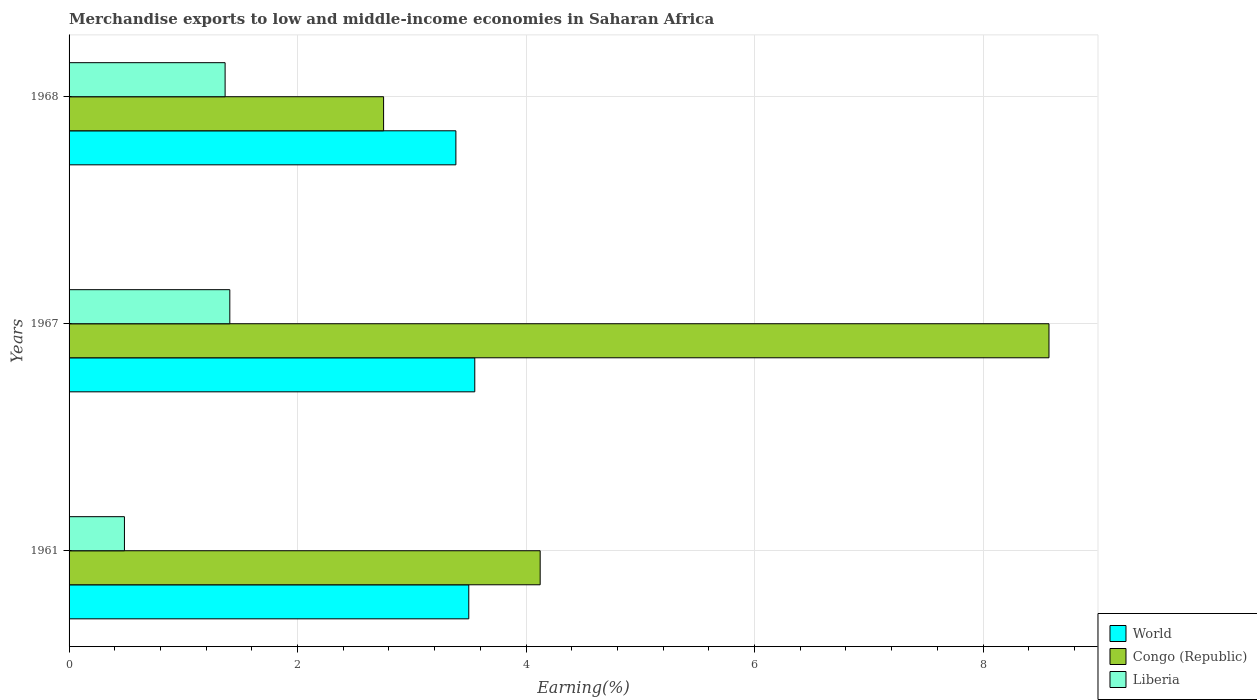Are the number of bars per tick equal to the number of legend labels?
Your answer should be compact. Yes. Are the number of bars on each tick of the Y-axis equal?
Keep it short and to the point. Yes. How many bars are there on the 1st tick from the top?
Keep it short and to the point. 3. How many bars are there on the 3rd tick from the bottom?
Make the answer very short. 3. What is the percentage of amount earned from merchandise exports in World in 1968?
Offer a very short reply. 3.39. Across all years, what is the maximum percentage of amount earned from merchandise exports in Liberia?
Your answer should be compact. 1.41. Across all years, what is the minimum percentage of amount earned from merchandise exports in Liberia?
Your answer should be very brief. 0.48. In which year was the percentage of amount earned from merchandise exports in Congo (Republic) maximum?
Provide a succinct answer. 1967. In which year was the percentage of amount earned from merchandise exports in World minimum?
Offer a terse response. 1968. What is the total percentage of amount earned from merchandise exports in Liberia in the graph?
Your answer should be compact. 3.26. What is the difference between the percentage of amount earned from merchandise exports in Congo (Republic) in 1961 and that in 1967?
Ensure brevity in your answer.  -4.45. What is the difference between the percentage of amount earned from merchandise exports in Liberia in 1961 and the percentage of amount earned from merchandise exports in Congo (Republic) in 1968?
Offer a terse response. -2.27. What is the average percentage of amount earned from merchandise exports in World per year?
Make the answer very short. 3.48. In the year 1967, what is the difference between the percentage of amount earned from merchandise exports in World and percentage of amount earned from merchandise exports in Congo (Republic)?
Your answer should be very brief. -5.03. In how many years, is the percentage of amount earned from merchandise exports in Congo (Republic) greater than 8 %?
Make the answer very short. 1. What is the ratio of the percentage of amount earned from merchandise exports in Congo (Republic) in 1967 to that in 1968?
Make the answer very short. 3.12. What is the difference between the highest and the second highest percentage of amount earned from merchandise exports in Congo (Republic)?
Make the answer very short. 4.45. What is the difference between the highest and the lowest percentage of amount earned from merchandise exports in Congo (Republic)?
Offer a very short reply. 5.82. What does the 1st bar from the top in 1961 represents?
Your answer should be compact. Liberia. Does the graph contain any zero values?
Give a very brief answer. No. Where does the legend appear in the graph?
Give a very brief answer. Bottom right. How many legend labels are there?
Offer a very short reply. 3. What is the title of the graph?
Offer a very short reply. Merchandise exports to low and middle-income economies in Saharan Africa. Does "Kenya" appear as one of the legend labels in the graph?
Provide a short and direct response. No. What is the label or title of the X-axis?
Provide a succinct answer. Earning(%). What is the Earning(%) in World in 1961?
Offer a terse response. 3.5. What is the Earning(%) in Congo (Republic) in 1961?
Offer a terse response. 4.12. What is the Earning(%) of Liberia in 1961?
Give a very brief answer. 0.48. What is the Earning(%) of World in 1967?
Give a very brief answer. 3.55. What is the Earning(%) in Congo (Republic) in 1967?
Ensure brevity in your answer.  8.58. What is the Earning(%) in Liberia in 1967?
Provide a short and direct response. 1.41. What is the Earning(%) of World in 1968?
Your answer should be very brief. 3.39. What is the Earning(%) in Congo (Republic) in 1968?
Give a very brief answer. 2.75. What is the Earning(%) in Liberia in 1968?
Your answer should be very brief. 1.37. Across all years, what is the maximum Earning(%) in World?
Offer a very short reply. 3.55. Across all years, what is the maximum Earning(%) in Congo (Republic)?
Offer a terse response. 8.58. Across all years, what is the maximum Earning(%) in Liberia?
Your answer should be very brief. 1.41. Across all years, what is the minimum Earning(%) in World?
Keep it short and to the point. 3.39. Across all years, what is the minimum Earning(%) in Congo (Republic)?
Keep it short and to the point. 2.75. Across all years, what is the minimum Earning(%) in Liberia?
Your response must be concise. 0.48. What is the total Earning(%) in World in the graph?
Give a very brief answer. 10.44. What is the total Earning(%) of Congo (Republic) in the graph?
Offer a terse response. 15.45. What is the total Earning(%) of Liberia in the graph?
Ensure brevity in your answer.  3.26. What is the difference between the Earning(%) in World in 1961 and that in 1967?
Keep it short and to the point. -0.05. What is the difference between the Earning(%) in Congo (Republic) in 1961 and that in 1967?
Provide a succinct answer. -4.45. What is the difference between the Earning(%) of Liberia in 1961 and that in 1967?
Your answer should be compact. -0.92. What is the difference between the Earning(%) in World in 1961 and that in 1968?
Your response must be concise. 0.11. What is the difference between the Earning(%) of Congo (Republic) in 1961 and that in 1968?
Offer a terse response. 1.37. What is the difference between the Earning(%) of Liberia in 1961 and that in 1968?
Give a very brief answer. -0.88. What is the difference between the Earning(%) in World in 1967 and that in 1968?
Make the answer very short. 0.17. What is the difference between the Earning(%) of Congo (Republic) in 1967 and that in 1968?
Your response must be concise. 5.82. What is the difference between the Earning(%) in Liberia in 1967 and that in 1968?
Your answer should be compact. 0.04. What is the difference between the Earning(%) of World in 1961 and the Earning(%) of Congo (Republic) in 1967?
Make the answer very short. -5.08. What is the difference between the Earning(%) of World in 1961 and the Earning(%) of Liberia in 1967?
Your answer should be compact. 2.09. What is the difference between the Earning(%) of Congo (Republic) in 1961 and the Earning(%) of Liberia in 1967?
Provide a short and direct response. 2.72. What is the difference between the Earning(%) of World in 1961 and the Earning(%) of Congo (Republic) in 1968?
Provide a succinct answer. 0.75. What is the difference between the Earning(%) of World in 1961 and the Earning(%) of Liberia in 1968?
Provide a succinct answer. 2.13. What is the difference between the Earning(%) of Congo (Republic) in 1961 and the Earning(%) of Liberia in 1968?
Offer a terse response. 2.76. What is the difference between the Earning(%) in World in 1967 and the Earning(%) in Congo (Republic) in 1968?
Provide a short and direct response. 0.8. What is the difference between the Earning(%) in World in 1967 and the Earning(%) in Liberia in 1968?
Make the answer very short. 2.19. What is the difference between the Earning(%) of Congo (Republic) in 1967 and the Earning(%) of Liberia in 1968?
Make the answer very short. 7.21. What is the average Earning(%) in World per year?
Your answer should be very brief. 3.48. What is the average Earning(%) of Congo (Republic) per year?
Offer a terse response. 5.15. What is the average Earning(%) in Liberia per year?
Keep it short and to the point. 1.09. In the year 1961, what is the difference between the Earning(%) of World and Earning(%) of Congo (Republic)?
Give a very brief answer. -0.62. In the year 1961, what is the difference between the Earning(%) in World and Earning(%) in Liberia?
Your response must be concise. 3.01. In the year 1961, what is the difference between the Earning(%) in Congo (Republic) and Earning(%) in Liberia?
Give a very brief answer. 3.64. In the year 1967, what is the difference between the Earning(%) of World and Earning(%) of Congo (Republic)?
Ensure brevity in your answer.  -5.03. In the year 1967, what is the difference between the Earning(%) in World and Earning(%) in Liberia?
Make the answer very short. 2.14. In the year 1967, what is the difference between the Earning(%) in Congo (Republic) and Earning(%) in Liberia?
Keep it short and to the point. 7.17. In the year 1968, what is the difference between the Earning(%) in World and Earning(%) in Congo (Republic)?
Make the answer very short. 0.63. In the year 1968, what is the difference between the Earning(%) of World and Earning(%) of Liberia?
Give a very brief answer. 2.02. In the year 1968, what is the difference between the Earning(%) of Congo (Republic) and Earning(%) of Liberia?
Your response must be concise. 1.39. What is the ratio of the Earning(%) in World in 1961 to that in 1967?
Make the answer very short. 0.99. What is the ratio of the Earning(%) of Congo (Republic) in 1961 to that in 1967?
Offer a terse response. 0.48. What is the ratio of the Earning(%) in Liberia in 1961 to that in 1967?
Offer a very short reply. 0.34. What is the ratio of the Earning(%) of Congo (Republic) in 1961 to that in 1968?
Provide a short and direct response. 1.5. What is the ratio of the Earning(%) in Liberia in 1961 to that in 1968?
Make the answer very short. 0.35. What is the ratio of the Earning(%) of World in 1967 to that in 1968?
Keep it short and to the point. 1.05. What is the ratio of the Earning(%) of Congo (Republic) in 1967 to that in 1968?
Provide a short and direct response. 3.12. What is the ratio of the Earning(%) in Liberia in 1967 to that in 1968?
Make the answer very short. 1.03. What is the difference between the highest and the second highest Earning(%) of World?
Offer a terse response. 0.05. What is the difference between the highest and the second highest Earning(%) of Congo (Republic)?
Provide a succinct answer. 4.45. What is the difference between the highest and the second highest Earning(%) of Liberia?
Make the answer very short. 0.04. What is the difference between the highest and the lowest Earning(%) in World?
Provide a short and direct response. 0.17. What is the difference between the highest and the lowest Earning(%) in Congo (Republic)?
Your answer should be compact. 5.82. What is the difference between the highest and the lowest Earning(%) of Liberia?
Keep it short and to the point. 0.92. 